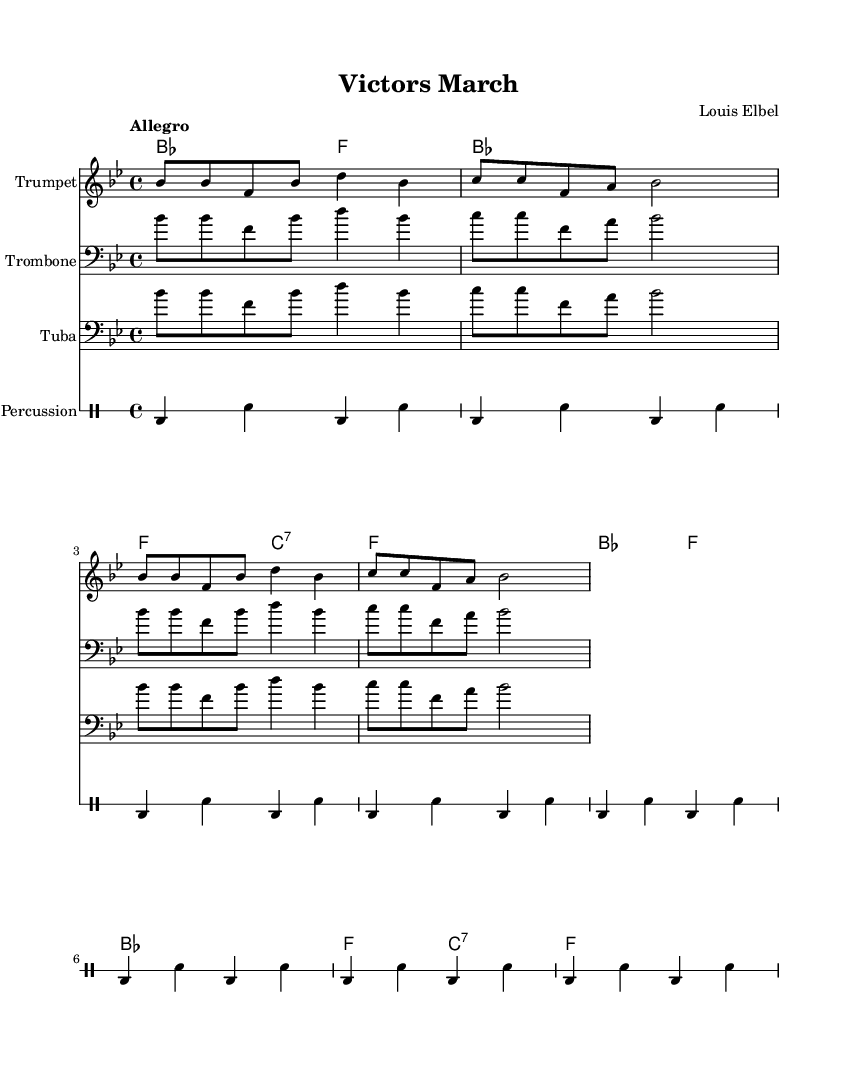What is the key signature of this music? The key signature is B flat major, which is indicated by the presence of two flats (B flat and E flat) in the key signature section of the sheet music.
Answer: B flat major What is the time signature of this music? The time signature is 4/4, which is indicated at the beginning of the score and shows that there are four beats in each measure, with a quarter note receiving one beat.
Answer: 4/4 What is the tempo marking of this piece? The tempo marking shows "Allegro," which is typically interpreted as a fast and lively pace, often around 120 to 168 beats per minute, indicated in the tempo indication at the beginning of the music.
Answer: Allegro How many measures are present in the melody section? By counting the measures provided in the melody, there are a total of 8 measures, which consist of repetitive melodic phrases outlined in the score.
Answer: 8 Which instrument is notated in the trumpet staff? The trumpet staff is specifically labeled with the instrument name "Trumpet", making it clear that this part is designated for the trumpet to play, as seen in the staff's instrumentation noted at the beginning.
Answer: Trumpet What chord follows the first measure? The chord that follows the first measure of the melody is B flat major, as indicated in the harmonies section which shows the chord changes corresponding to the beginning of the piece.
Answer: B flat 